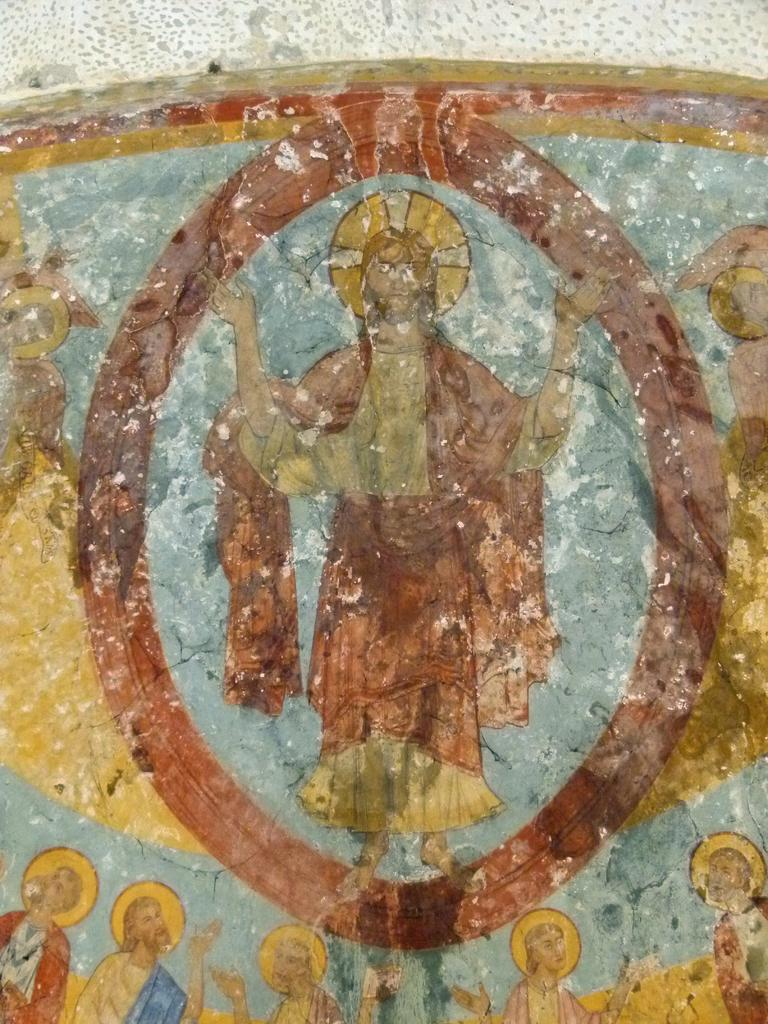What is present on the wall in the image? There is art on the wall in the image. What else can be seen in the image besides the wall and the art? There are people in the image. How many glasses of water are being held by the people in the image? There is no reference to glasses of water or any liquid in the image. Are there any spiders visible on the wall or the art in the image? There is no mention of spiders in the image, and they are not visible in the provided facts. 